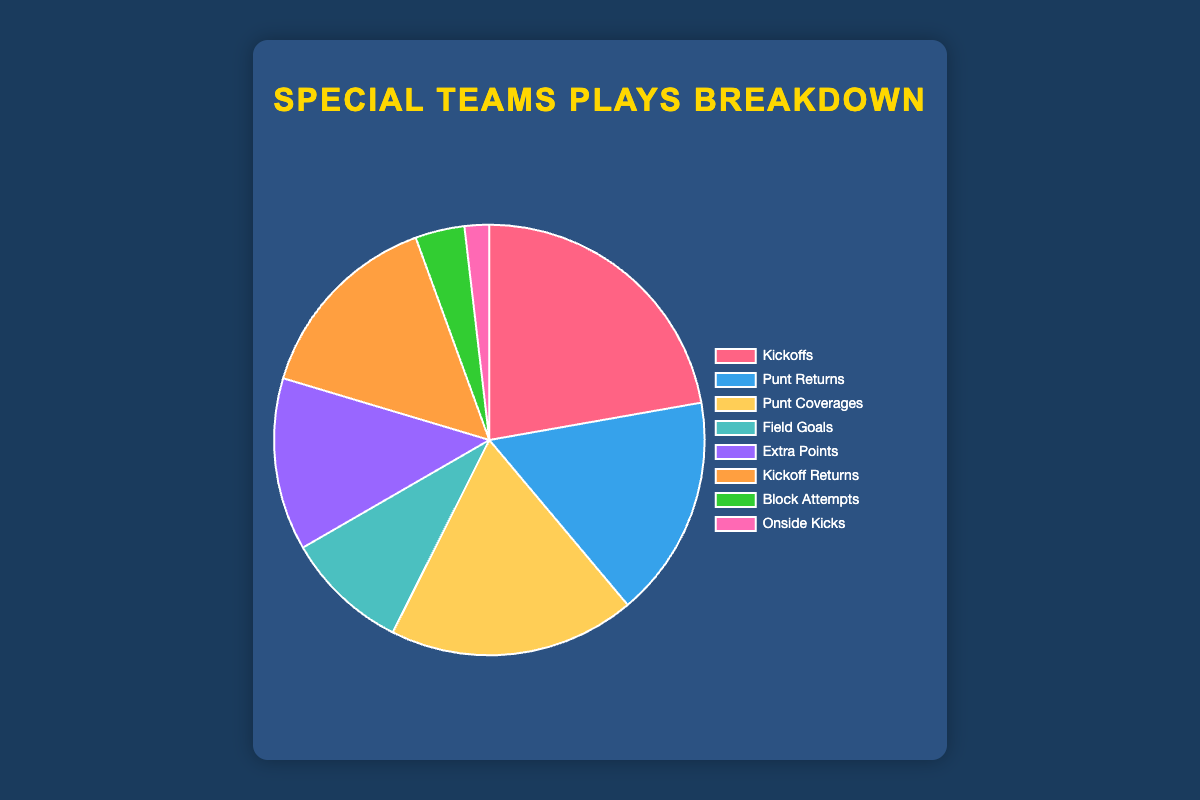Which type of special teams play has the highest count? By looking at the largest segment in the pie chart and its label, we can identify the type with the highest count. The "Kickoffs" section represents the highest count visually.
Answer: Kickoffs How many more punt coverages are there than field goals? Identify the segments for "Punt Coverages" and "Field Goals" on the pie chart. Punt coverages have 50 and field goals have 25. Subtract the count of field goals from punt coverages: 50 - 25 = 25.
Answer: 25 Which has fewer counts: block attempts or onside kicks? Find the segments for "Block Attempts" and "Onside Kicks" on the pie chart. Block attempts have 10 and onside kicks have 5. Compare the two values to see which is smaller.
Answer: Onside Kicks What is the total count of special teams plays related to "returns" (i.e., punt returns and kickoff returns)? Find the values for "Punt Returns" and "Kickoff Returns" on the pie chart and sum them. Punt returns have 45 and kickoff returns have 40. Sum: 45 + 40 = 85.
Answer: 85 What percentage of the total plays are extra points? First, find the total number of special teams plays by summing all the counts: 60 + 45 + 50 + 25 + 35 + 40 + 10 + 5 = 270. Then, find the count of extra points which is 35. Calculate the percentage: (35 / 270) * 100 ≈ 12.96%.
Answer: ≈ 12.96% Is the count of kickoffs more than twice the count of field goals? Identify the counts for "Kickoffs" and "Field Goals" on the pie chart. Kickoffs have 60 and field goals have 25. Check if 60 is more than twice 25: 2 * 25 = 50, and 60 > 50.
Answer: Yes How many combined plays are executed for kickoffs and block attempts? Find the counts for "Kickoffs" and "Block Attempts" on the pie chart and sum them. Kickoffs have 60 and block attempts have 10. Sum: 60 + 10 = 70.
Answer: 70 Which has a higher count: onside kicks or extra points? Identify the segments for "Onside Kicks" and "Extra Points" on the pie chart. Onside kicks have 5 and extra points have 35. Compare the two values to see which is greater.
Answer: Extra Points What proportion of plays are field goals and onside kicks combined, out of the total? First, find the total number of special teams plays by summing all the counts: 60 + 45 + 50 + 25 + 35 + 40 + 10 + 5 = 270. Then, add the counts of field goals (25) and onside kicks (5): 25 + 5 = 30. Calculate the proportion: 30 / 270 ≈ 0.111.
Answer: ≈ 0.111 